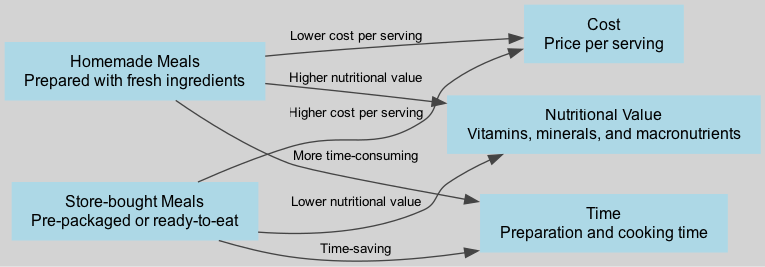What is the nutritional comparison of homemade meals to store-bought meals? Homemade meals have a higher nutritional value compared to store-bought meals, which have a lower nutritional value according to the diagram.
Answer: Higher nutritional value How many nodes are present in the diagram? The diagram has six nodes: 1. Homemade Meals 2. Store-bought Meals 3. Nutritional Value 4. Cost 5. Time. Therefore, the total number of nodes is six.
Answer: 6 What is the relationship between homemade meals and cost? According to the diagram, homemade meals have a lower cost per serving, indicating a beneficial financial aspect of preparing meals at home compared to store-bought meals.
Answer: Lower cost per serving Which type of meal is described as time-saving? The diagram explicitly states that store-bought meals are time-saving, in contrast to homemade meals, which are noted as more time-consuming.
Answer: Store-bought meals Which meal type requires more preparation time? The edge connecting homemade meals to time shows that they are more time-consuming than store-bought meals, thus indicating that homemade meals require more preparation time.
Answer: Homemade meals What is the cost comparison between homemade and store-bought meals per serving? The diagram clearly shows that homemade meals are associated with a lower cost per serving compared to store-bought meals, which are depicted as having a higher cost per serving.
Answer: Lower cost per serving Explain the nutritional value related to store-bought meals. The diagram presents that store-bought meals are linked to lower nutritional value. Therefore, store-bought meals are less nutritious compared to homemade meals based on the information provided.
Answer: Lower nutritional value What indicates that homemade meals are more complex to prepare? In the diagram, the connection from homemade meals to time suggests that they are more time-consuming, implying that preparation may be more complex compared to store-bought meals described as time-saving.
Answer: More time-consuming What is the primary focus of the diagram? The primary focus of the diagram is to illustrate the nutritional and cost comparison between homemade and store-bought meals, demonstrating different aspects such as nutrition, cost, and preparation time.
Answer: Nutrition and cost comparison 